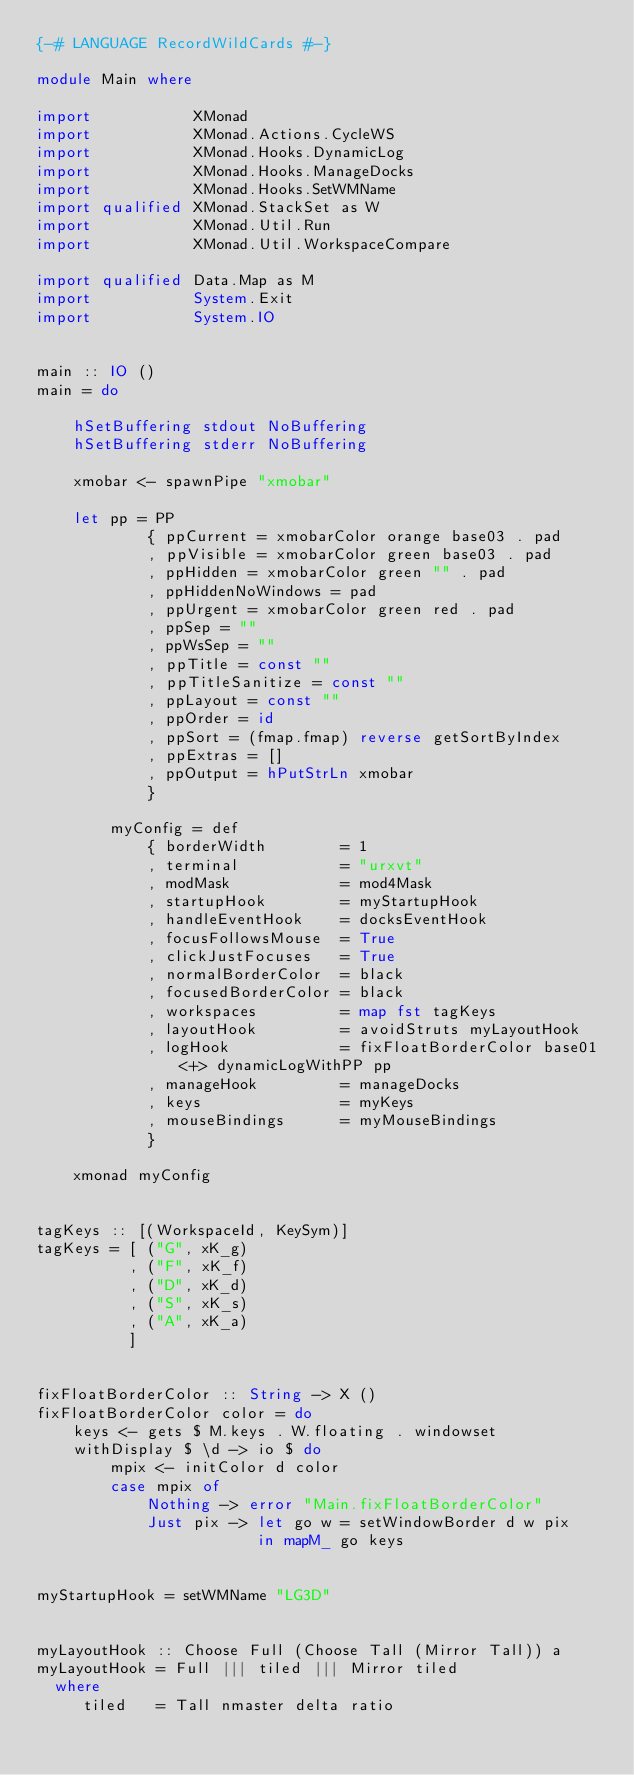<code> <loc_0><loc_0><loc_500><loc_500><_Haskell_>{-# LANGUAGE RecordWildCards #-}

module Main where

import           XMonad
import           XMonad.Actions.CycleWS
import           XMonad.Hooks.DynamicLog
import           XMonad.Hooks.ManageDocks
import           XMonad.Hooks.SetWMName
import qualified XMonad.StackSet as W
import           XMonad.Util.Run
import           XMonad.Util.WorkspaceCompare

import qualified Data.Map as M
import           System.Exit
import           System.IO


main :: IO ()
main = do

    hSetBuffering stdout NoBuffering
    hSetBuffering stderr NoBuffering

    xmobar <- spawnPipe "xmobar"

    let pp = PP
            { ppCurrent = xmobarColor orange base03 . pad
            , ppVisible = xmobarColor green base03 . pad
            , ppHidden = xmobarColor green "" . pad
            , ppHiddenNoWindows = pad
            , ppUrgent = xmobarColor green red . pad
            , ppSep = ""
            , ppWsSep = ""
            , ppTitle = const ""
            , ppTitleSanitize = const ""
            , ppLayout = const ""
            , ppOrder = id
            , ppSort = (fmap.fmap) reverse getSortByIndex
            , ppExtras = []
            , ppOutput = hPutStrLn xmobar
            }

        myConfig = def
            { borderWidth        = 1
            , terminal           = "urxvt"
            , modMask            = mod4Mask
            , startupHook        = myStartupHook
            , handleEventHook    = docksEventHook
            , focusFollowsMouse  = True
            , clickJustFocuses   = True
            , normalBorderColor  = black
            , focusedBorderColor = black
            , workspaces         = map fst tagKeys
            , layoutHook         = avoidStruts myLayoutHook
            , logHook            = fixFloatBorderColor base01 <+> dynamicLogWithPP pp
            , manageHook         = manageDocks
            , keys               = myKeys
            , mouseBindings      = myMouseBindings
            }

    xmonad myConfig


tagKeys :: [(WorkspaceId, KeySym)]
tagKeys = [ ("G", xK_g)
          , ("F", xK_f)
          , ("D", xK_d)
          , ("S", xK_s)
          , ("A", xK_a)
          ]


fixFloatBorderColor :: String -> X ()
fixFloatBorderColor color = do
    keys <- gets $ M.keys . W.floating . windowset
    withDisplay $ \d -> io $ do
        mpix <- initColor d color
        case mpix of
            Nothing -> error "Main.fixFloatBorderColor"
            Just pix -> let go w = setWindowBorder d w pix
                        in mapM_ go keys


myStartupHook = setWMName "LG3D"


myLayoutHook :: Choose Full (Choose Tall (Mirror Tall)) a
myLayoutHook = Full ||| tiled ||| Mirror tiled
  where
     tiled   = Tall nmaster delta ratio</code> 